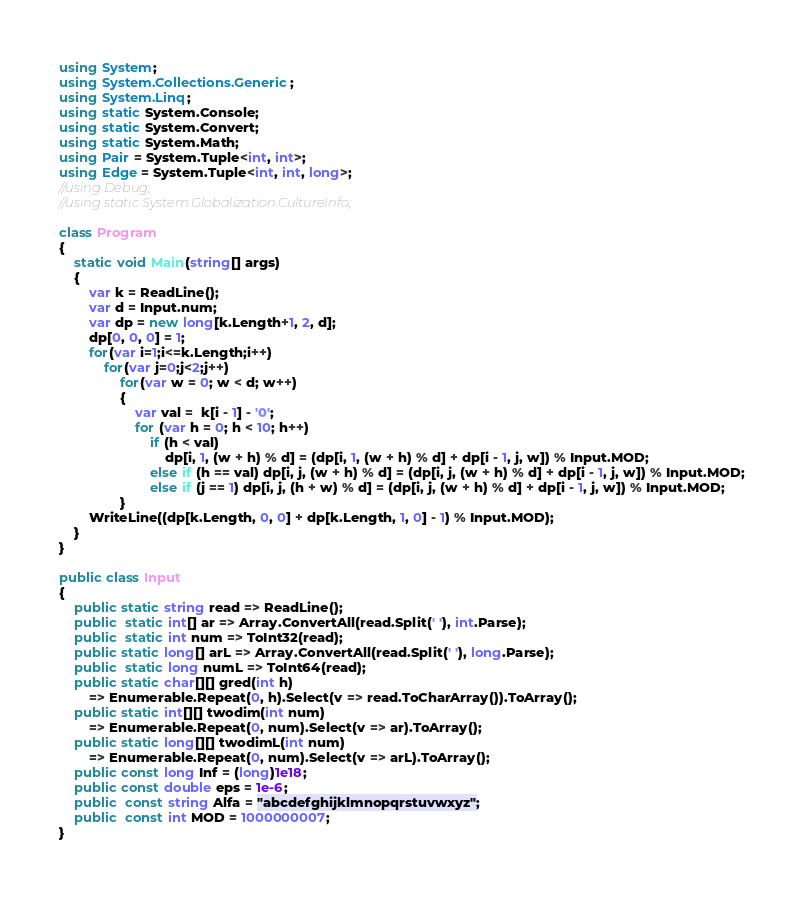Convert code to text. <code><loc_0><loc_0><loc_500><loc_500><_C#_>using System;
using System.Collections.Generic;
using System.Linq;
using static System.Console;
using static System.Convert;
using static System.Math;
using Pair = System.Tuple<int, int>;
using Edge = System.Tuple<int, int, long>;
//using Debug;
//using static System.Globalization.CultureInfo;

class Program
{
    static void Main(string[] args)
    {
        var k = ReadLine();
        var d = Input.num;
        var dp = new long[k.Length+1, 2, d];
        dp[0, 0, 0] = 1;
        for(var i=1;i<=k.Length;i++)
            for(var j=0;j<2;j++)
                for(var w = 0; w < d; w++)
                {
                    var val =  k[i - 1] - '0';
                    for (var h = 0; h < 10; h++)
                        if (h < val)
                            dp[i, 1, (w + h) % d] = (dp[i, 1, (w + h) % d] + dp[i - 1, j, w]) % Input.MOD;
                        else if (h == val) dp[i, j, (w + h) % d] = (dp[i, j, (w + h) % d] + dp[i - 1, j, w]) % Input.MOD;
                        else if (j == 1) dp[i, j, (h + w) % d] = (dp[i, j, (w + h) % d] + dp[i - 1, j, w]) % Input.MOD;
                }
        WriteLine((dp[k.Length, 0, 0] + dp[k.Length, 1, 0] - 1) % Input.MOD);
    }
}

public class Input
{
    public static string read => ReadLine();
    public  static int[] ar => Array.ConvertAll(read.Split(' '), int.Parse);
    public  static int num => ToInt32(read);
    public static long[] arL => Array.ConvertAll(read.Split(' '), long.Parse);
    public  static long numL => ToInt64(read);
    public static char[][] gred(int h) 
        => Enumerable.Repeat(0, h).Select(v => read.ToCharArray()).ToArray();
    public static int[][] twodim(int num)
        => Enumerable.Repeat(0, num).Select(v => ar).ToArray();
    public static long[][] twodimL(int num)
        => Enumerable.Repeat(0, num).Select(v => arL).ToArray();
    public const long Inf = (long)1e18;
    public const double eps = 1e-6;
    public  const string Alfa = "abcdefghijklmnopqrstuvwxyz";
    public  const int MOD = 1000000007;
}
</code> 